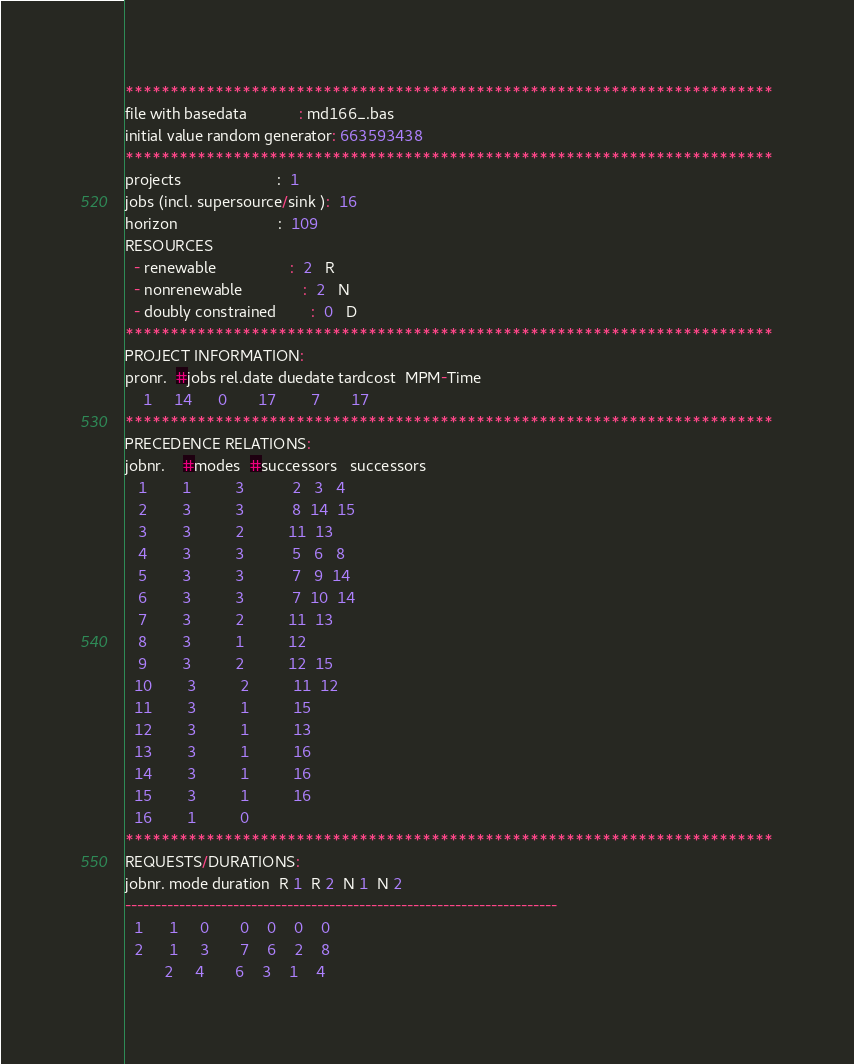Convert code to text. <code><loc_0><loc_0><loc_500><loc_500><_ObjectiveC_>************************************************************************
file with basedata            : md166_.bas
initial value random generator: 663593438
************************************************************************
projects                      :  1
jobs (incl. supersource/sink ):  16
horizon                       :  109
RESOURCES
  - renewable                 :  2   R
  - nonrenewable              :  2   N
  - doubly constrained        :  0   D
************************************************************************
PROJECT INFORMATION:
pronr.  #jobs rel.date duedate tardcost  MPM-Time
    1     14      0       17        7       17
************************************************************************
PRECEDENCE RELATIONS:
jobnr.    #modes  #successors   successors
   1        1          3           2   3   4
   2        3          3           8  14  15
   3        3          2          11  13
   4        3          3           5   6   8
   5        3          3           7   9  14
   6        3          3           7  10  14
   7        3          2          11  13
   8        3          1          12
   9        3          2          12  15
  10        3          2          11  12
  11        3          1          15
  12        3          1          13
  13        3          1          16
  14        3          1          16
  15        3          1          16
  16        1          0        
************************************************************************
REQUESTS/DURATIONS:
jobnr. mode duration  R 1  R 2  N 1  N 2
------------------------------------------------------------------------
  1      1     0       0    0    0    0
  2      1     3       7    6    2    8
         2     4       6    3    1    4</code> 